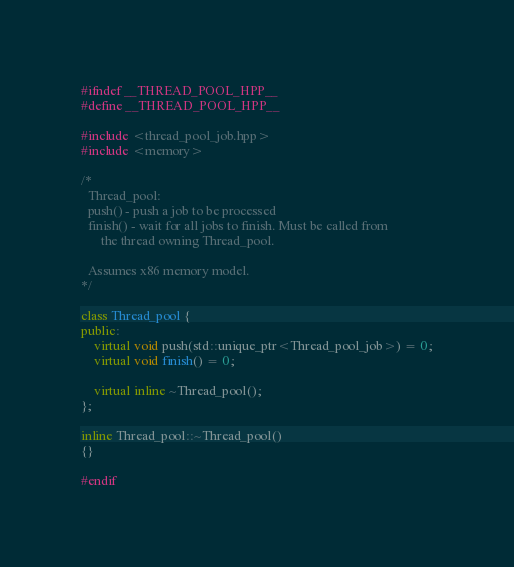Convert code to text. <code><loc_0><loc_0><loc_500><loc_500><_C++_>#ifndef __THREAD_POOL_HPP__
#define __THREAD_POOL_HPP__

#include <thread_pool_job.hpp>
#include <memory>

/*
  Thread_pool:
  push() - push a job to be processed
  finish() - wait for all jobs to finish. Must be called from
      the thread owning Thread_pool.

  Assumes x86 memory model.
*/

class Thread_pool {
public:
    virtual void push(std::unique_ptr<Thread_pool_job>) = 0;
    virtual void finish() = 0;

    virtual inline ~Thread_pool();
};

inline Thread_pool::~Thread_pool()
{}

#endif
</code> 